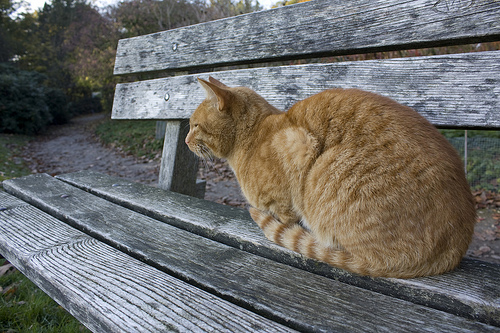How many animals can you spot? There is one animal visible in the image, a gold-colored cat sitting on the bench. What do you think the cat is looking at? The cat seems to be looking off into the distance, possibly observing something in the surrounding area or just enjoying the tranquil environment. 